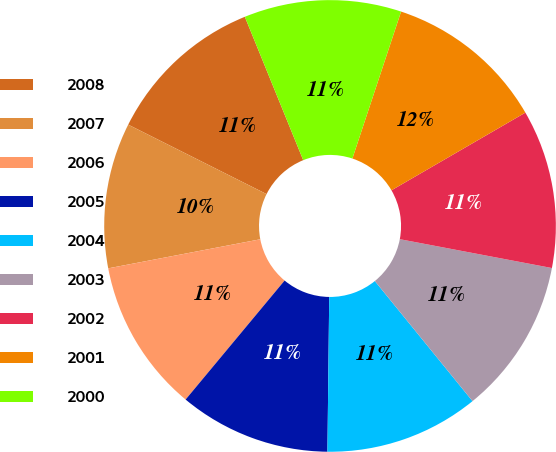Convert chart. <chart><loc_0><loc_0><loc_500><loc_500><pie_chart><fcel>2008<fcel>2007<fcel>2006<fcel>2005<fcel>2004<fcel>2003<fcel>2002<fcel>2001<fcel>2000<nl><fcel>11.44%<fcel>10.41%<fcel>10.95%<fcel>10.86%<fcel>11.05%<fcel>11.15%<fcel>11.35%<fcel>11.54%<fcel>11.25%<nl></chart> 